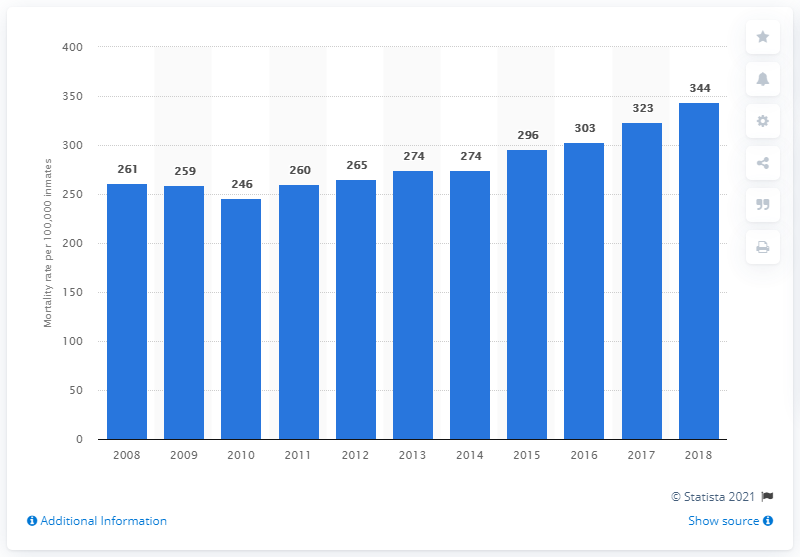Give some essential details in this illustration. In 2018, the mortality rate for state prisoners in the United States was 344 per 100,000 population. 